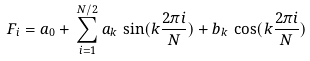Convert formula to latex. <formula><loc_0><loc_0><loc_500><loc_500>F _ { i } = a _ { 0 } + \, \sum _ { i = 1 } ^ { N / 2 } a _ { k } \, \sin ( k \frac { 2 \pi i } { N } ) + b _ { k } \, \cos ( k \frac { 2 \pi i } { N } )</formula> 